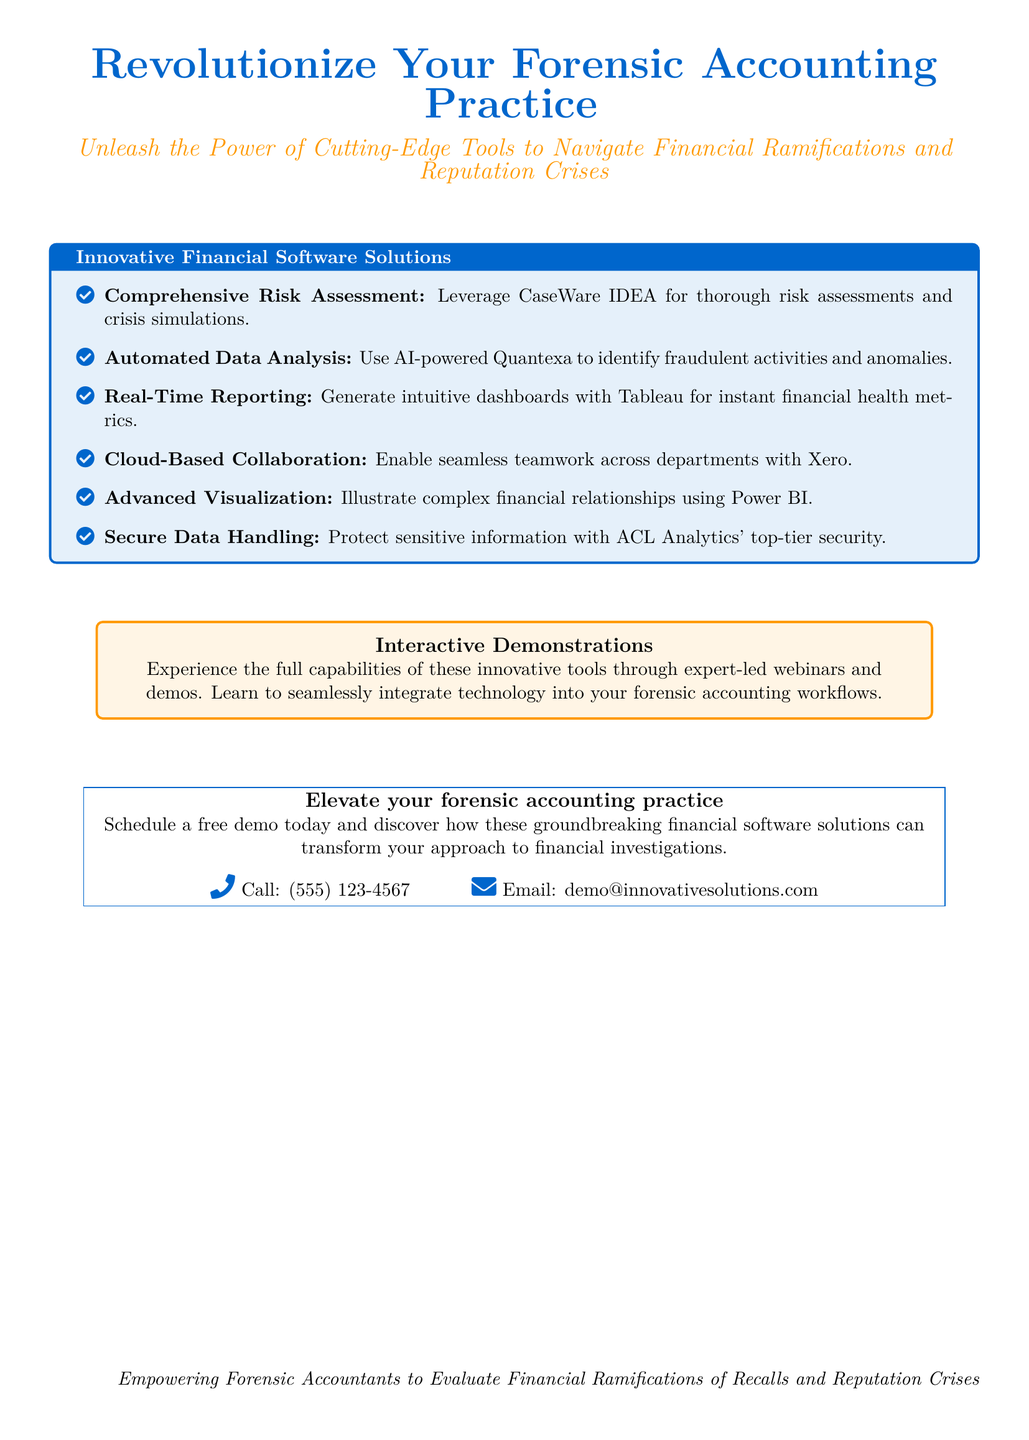What is the main focus of the advertisement? The main focus is to promote innovative financial software solutions for forensic accountants.
Answer: Innovative financial software solutions What is the contact phone number provided in the document? The contact phone number for inquiries is clearly listed in the advertisement.
Answer: (555) 123-4567 Which software is mentioned for automated data analysis? The document lists specific software solutions for various tasks in forensic accounting, including automated data analysis.
Answer: Quantexa What feature does Tableau provide according to the advertisement? The advertisement highlights certain capabilities of the software tools, specifically Tableau's function.
Answer: Real-Time Reporting What type of events can users expect to experience to learn about the software? The advertising includes interactive opportunities to familiarize users with the new tools.
Answer: Expert-led webinars What is the primary benefit highlighted for forensic accountants in the document? The document emphasizes enhancing forensic accounting practices through the adoption of innovative technologies.
Answer: Evaluate financial ramifications What company offers the advertised financial software solutions? The document is associated with a specific company that provides these innovative tools.
Answer: Innovative Solutions How does the advertisement suggest protecting sensitive information? The advertisement describes data security measures associated with one of the mentioned software tools.
Answer: ACL Analytics' top-tier security 